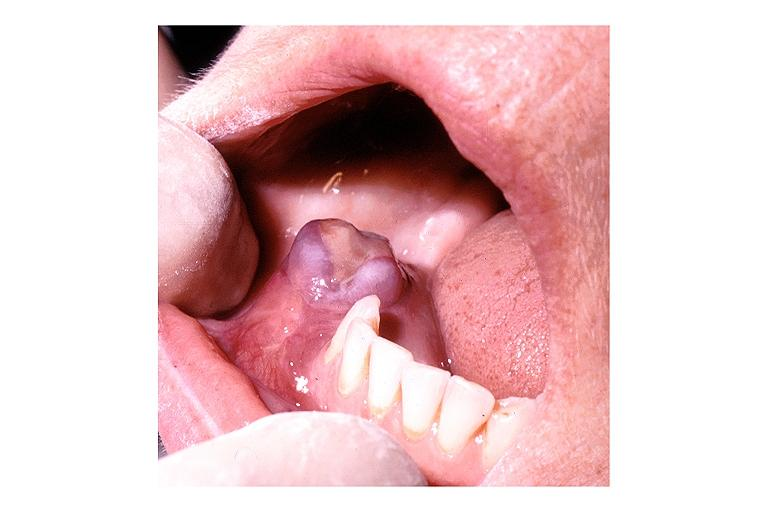s oral present?
Answer the question using a single word or phrase. Yes 